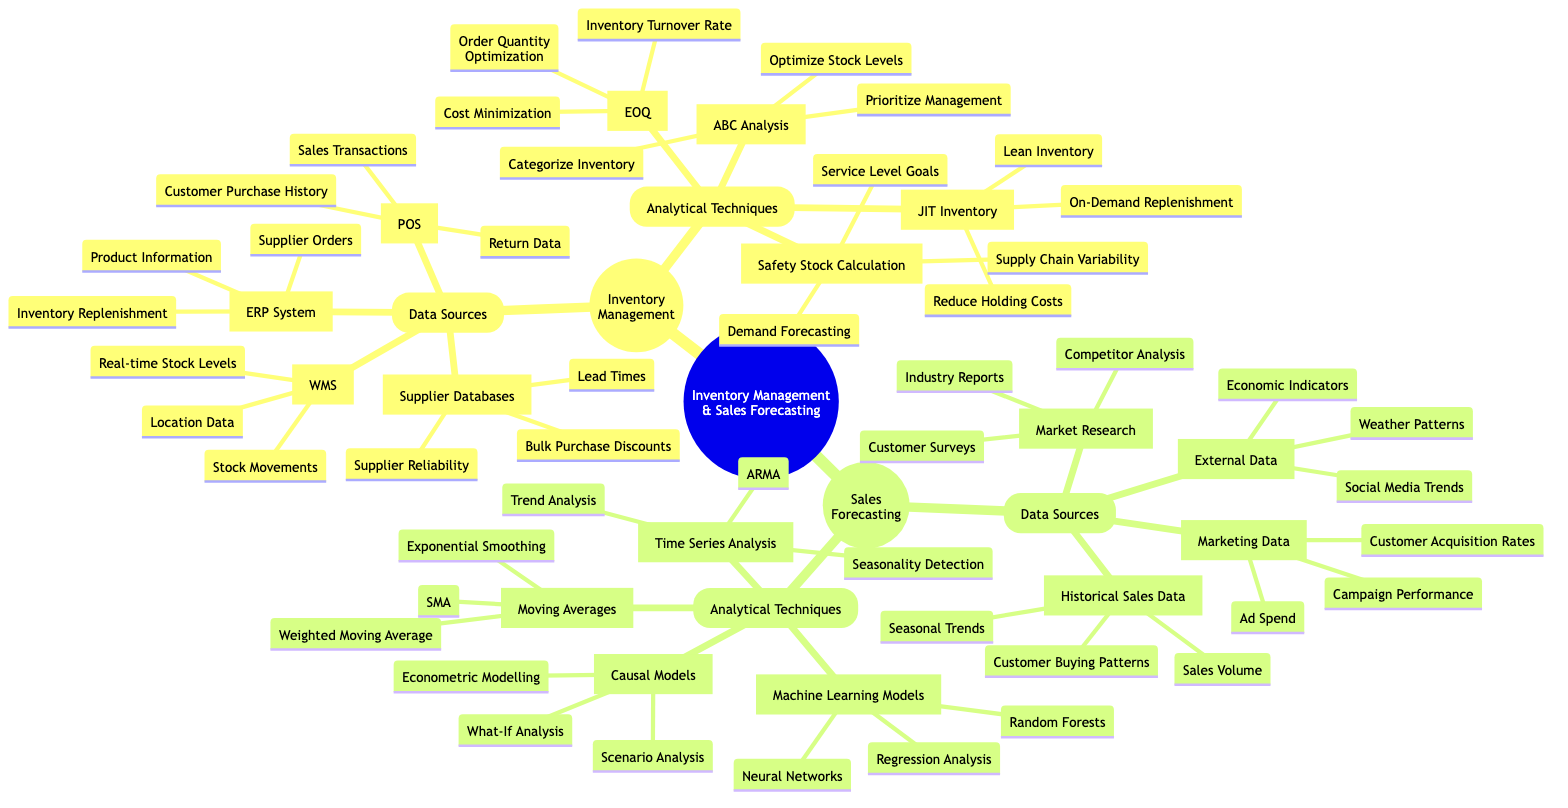What are the data sources for Inventory Management? The diagram lists four data sources for Inventory Management: Warehouse Management System, Enterprise Resource Planning System, Point of Sale, and Supplier Databases.
Answer: Warehouse Management System, Enterprise Resource Planning System, Point of Sale, Supplier Databases How many analytical techniques are listed under Sales Forecasting? The Sales Forecasting section of the diagram includes four analytical techniques: Time Series Analysis, Machine Learning Models, Causal Models, and Moving Averages, which totals to four techniques.
Answer: 4 Which data source includes customer surveys? From the Sales Forecasting section, the Market Research node explicitly mentions Customer Surveys as one of its data sources.
Answer: Market Research What does ABC Analysis optimize in Inventory Management? The ABC Analysis node indicates it is focused on optimizing stock levels, as it states that one of its components is "Optimize Stock Levels".
Answer: Optimize Stock Levels What relationship exists between Safety Stock Calculation and demand forecasting? Safety Stock Calculation depends on Demand Forecasting, as outlined in the diagram. It signifies that demand forecasting is critical for determining safety stock levels.
Answer: Depends on Which analytical technique uses regression analysis? The Machine Learning Models node lists Regression Analysis as one of its components, indicating that it is used within this analytical technique.
Answer: Machine Learning Models What does the acronym JIT stand for in Inventory Management? The JIT Inventory node represents "Just-In-Time," which is indicated in parentheses next to the JIT Inventory label in the diagram.
Answer: Just-In-Time Identify the analytical technique that focuses on seasonality detection. The Time Series Analysis node specifically mentions "Seasonality Detection" as one of its focuses, highlighting its relevance in analyzing seasonal patterns.
Answer: Time Series Analysis What is one of the external data sources mentioned in Sales Forecasting? The External Data node lists "Economic Indicators", which is one of the data sources indicated in the Sales Forecasting section.
Answer: Economic Indicators 